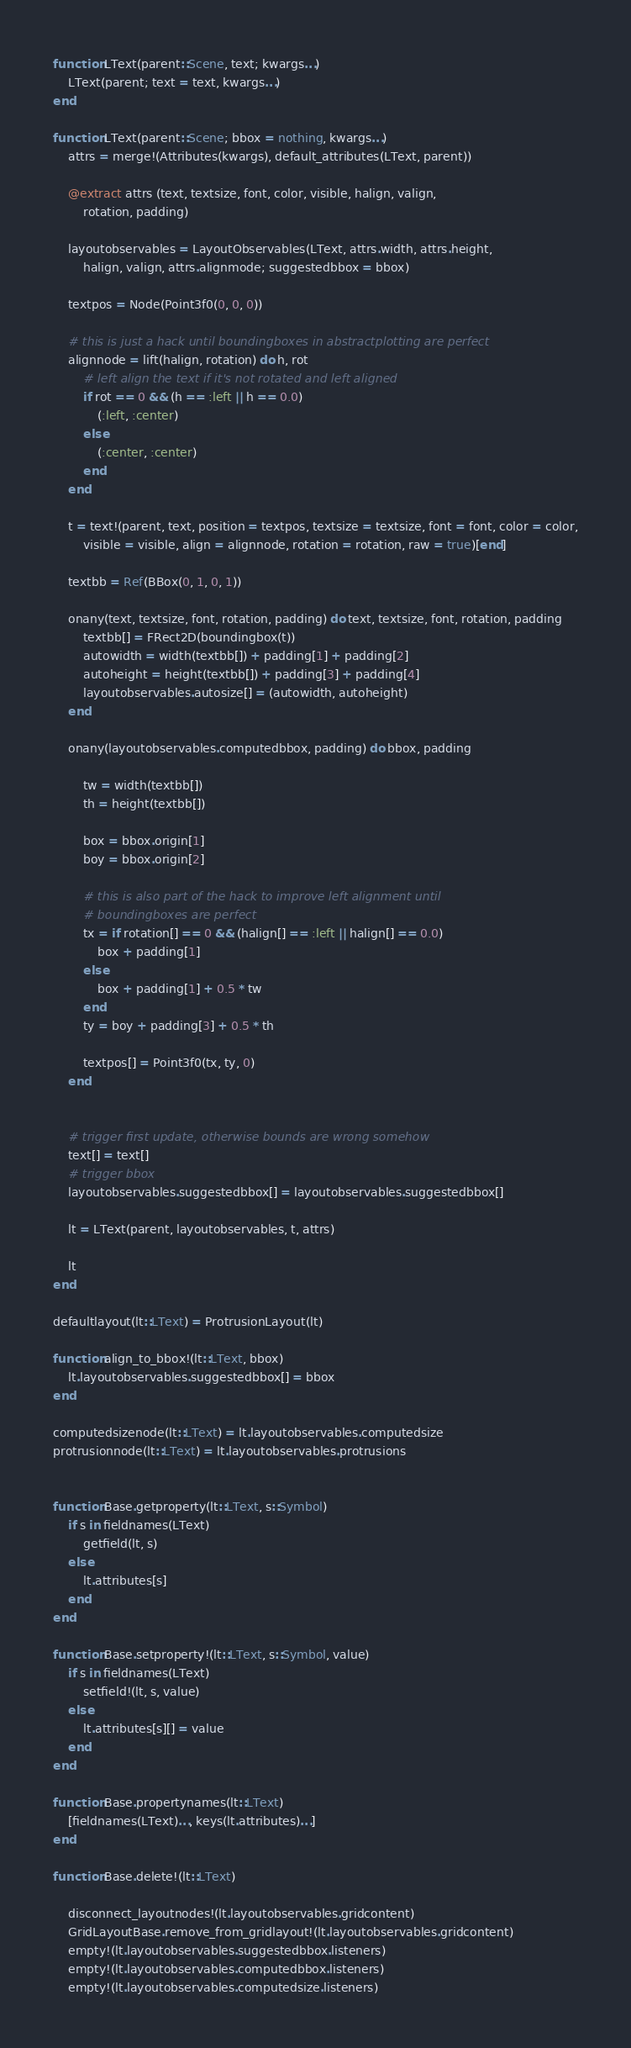<code> <loc_0><loc_0><loc_500><loc_500><_Julia_>function LText(parent::Scene, text; kwargs...)
    LText(parent; text = text, kwargs...)
end

function LText(parent::Scene; bbox = nothing, kwargs...)
    attrs = merge!(Attributes(kwargs), default_attributes(LText, parent))

    @extract attrs (text, textsize, font, color, visible, halign, valign,
        rotation, padding)

    layoutobservables = LayoutObservables(LText, attrs.width, attrs.height,
        halign, valign, attrs.alignmode; suggestedbbox = bbox)

    textpos = Node(Point3f0(0, 0, 0))

    # this is just a hack until boundingboxes in abstractplotting are perfect
    alignnode = lift(halign, rotation) do h, rot
        # left align the text if it's not rotated and left aligned
        if rot == 0 && (h == :left || h == 0.0)
            (:left, :center)
        else
            (:center, :center)
        end
    end

    t = text!(parent, text, position = textpos, textsize = textsize, font = font, color = color,
        visible = visible, align = alignnode, rotation = rotation, raw = true)[end]

    textbb = Ref(BBox(0, 1, 0, 1))

    onany(text, textsize, font, rotation, padding) do text, textsize, font, rotation, padding
        textbb[] = FRect2D(boundingbox(t))
        autowidth = width(textbb[]) + padding[1] + padding[2]
        autoheight = height(textbb[]) + padding[3] + padding[4]
        layoutobservables.autosize[] = (autowidth, autoheight)
    end

    onany(layoutobservables.computedbbox, padding) do bbox, padding

        tw = width(textbb[])
        th = height(textbb[])

        box = bbox.origin[1]
        boy = bbox.origin[2]

        # this is also part of the hack to improve left alignment until
        # boundingboxes are perfect
        tx = if rotation[] == 0 && (halign[] == :left || halign[] == 0.0)
            box + padding[1]
        else
            box + padding[1] + 0.5 * tw
        end
        ty = boy + padding[3] + 0.5 * th

        textpos[] = Point3f0(tx, ty, 0)
    end


    # trigger first update, otherwise bounds are wrong somehow
    text[] = text[]
    # trigger bbox
    layoutobservables.suggestedbbox[] = layoutobservables.suggestedbbox[]

    lt = LText(parent, layoutobservables, t, attrs)

    lt
end

defaultlayout(lt::LText) = ProtrusionLayout(lt)

function align_to_bbox!(lt::LText, bbox)
    lt.layoutobservables.suggestedbbox[] = bbox
end

computedsizenode(lt::LText) = lt.layoutobservables.computedsize
protrusionnode(lt::LText) = lt.layoutobservables.protrusions


function Base.getproperty(lt::LText, s::Symbol)
    if s in fieldnames(LText)
        getfield(lt, s)
    else
        lt.attributes[s]
    end
end

function Base.setproperty!(lt::LText, s::Symbol, value)
    if s in fieldnames(LText)
        setfield!(lt, s, value)
    else
        lt.attributes[s][] = value
    end
end

function Base.propertynames(lt::LText)
    [fieldnames(LText)..., keys(lt.attributes)...]
end

function Base.delete!(lt::LText)

    disconnect_layoutnodes!(lt.layoutobservables.gridcontent)
    GridLayoutBase.remove_from_gridlayout!(lt.layoutobservables.gridcontent)
    empty!(lt.layoutobservables.suggestedbbox.listeners)
    empty!(lt.layoutobservables.computedbbox.listeners)
    empty!(lt.layoutobservables.computedsize.listeners)</code> 